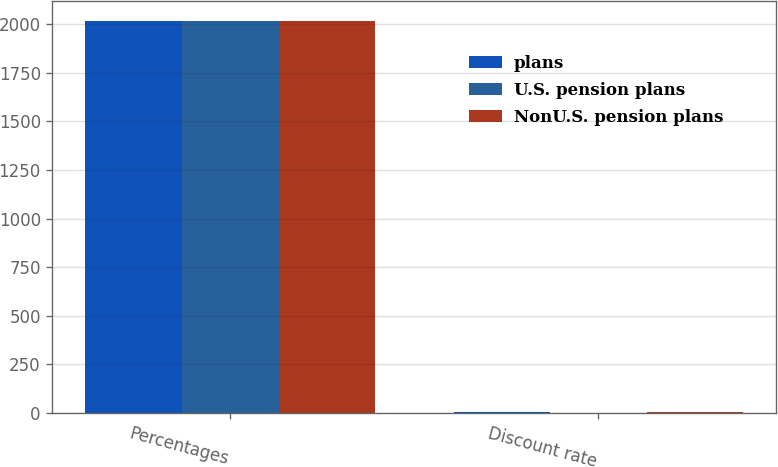<chart> <loc_0><loc_0><loc_500><loc_500><stacked_bar_chart><ecel><fcel>Percentages<fcel>Discount rate<nl><fcel>plans<fcel>2016<fcel>4.21<nl><fcel>U.S. pension plans<fcel>2016<fcel>2.52<nl><fcel>NonU.S. pension plans<fcel>2016<fcel>3.95<nl></chart> 